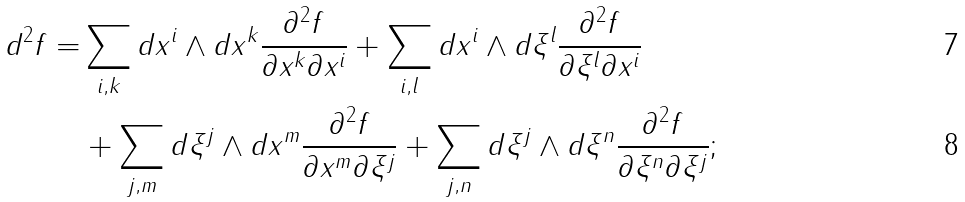Convert formula to latex. <formula><loc_0><loc_0><loc_500><loc_500>d ^ { 2 } f = & \sum _ { i , k } d x ^ { i } \wedge d x ^ { k } \frac { \partial ^ { 2 } f } { \partial x ^ { k } \partial x ^ { i } } + \sum _ { i , l } d x ^ { i } \wedge d \xi ^ { l } \frac { \partial ^ { 2 } f } { \partial \xi ^ { l } \partial x ^ { i } } \\ & + \sum _ { j , m } d \xi ^ { j } \wedge d x ^ { m } \frac { \partial ^ { 2 } f } { \partial x ^ { m } \partial \xi ^ { j } } + \sum _ { j , n } d \xi ^ { j } \wedge d \xi ^ { n } \frac { \partial ^ { 2 } f } { \partial \xi ^ { n } \partial \xi ^ { j } } ;</formula> 